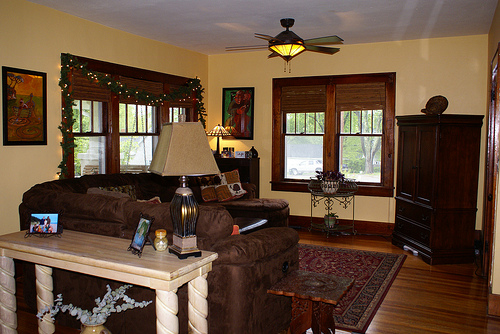Please provide a short description for this region: [0.23, 0.59, 0.31, 0.66]. A small, framed family portrait resting on a wooden table. 